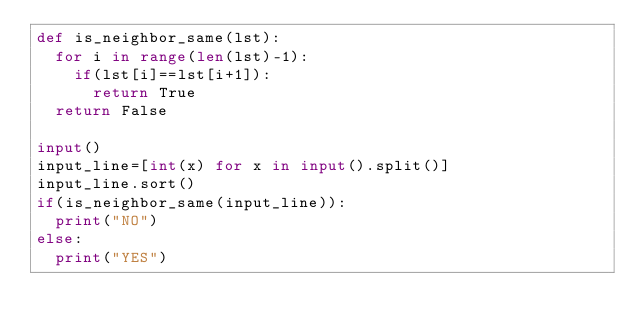<code> <loc_0><loc_0><loc_500><loc_500><_Python_>def is_neighbor_same(lst):
  for i in range(len(lst)-1):
    if(lst[i]==lst[i+1]):
      return True
  return False

input()
input_line=[int(x) for x in input().split()]
input_line.sort()
if(is_neighbor_same(input_line)):
  print("NO")
else:
  print("YES")
  </code> 